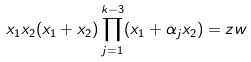<formula> <loc_0><loc_0><loc_500><loc_500>x _ { 1 } x _ { 2 } ( x _ { 1 } + x _ { 2 } ) \prod _ { j = 1 } ^ { k - 3 } ( x _ { 1 } + \alpha _ { j } x _ { 2 } ) = z w</formula> 